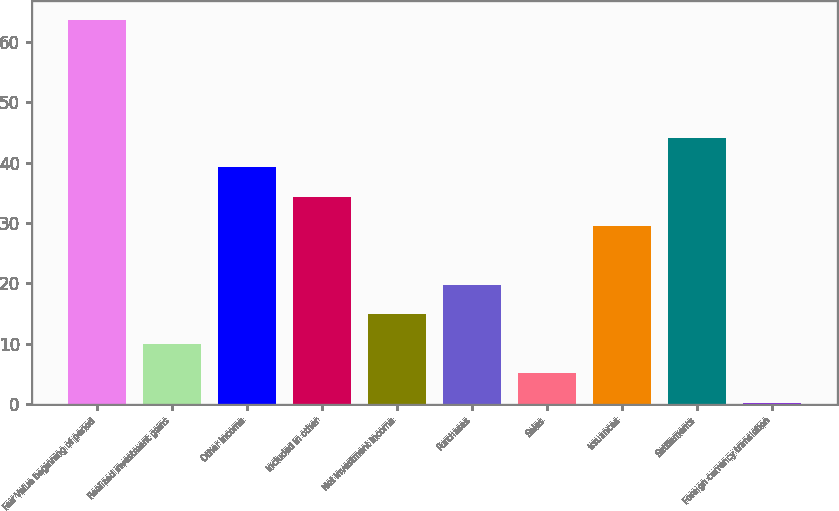<chart> <loc_0><loc_0><loc_500><loc_500><bar_chart><fcel>Fair Value beginning of period<fcel>Realized investment gains<fcel>Other income<fcel>Included in other<fcel>Net investment income<fcel>Purchases<fcel>Sales<fcel>Issuances<fcel>Settlements<fcel>Foreign currency translation<nl><fcel>63.6<fcel>10.03<fcel>39.25<fcel>34.38<fcel>14.9<fcel>19.77<fcel>5.16<fcel>29.51<fcel>44.12<fcel>0.29<nl></chart> 